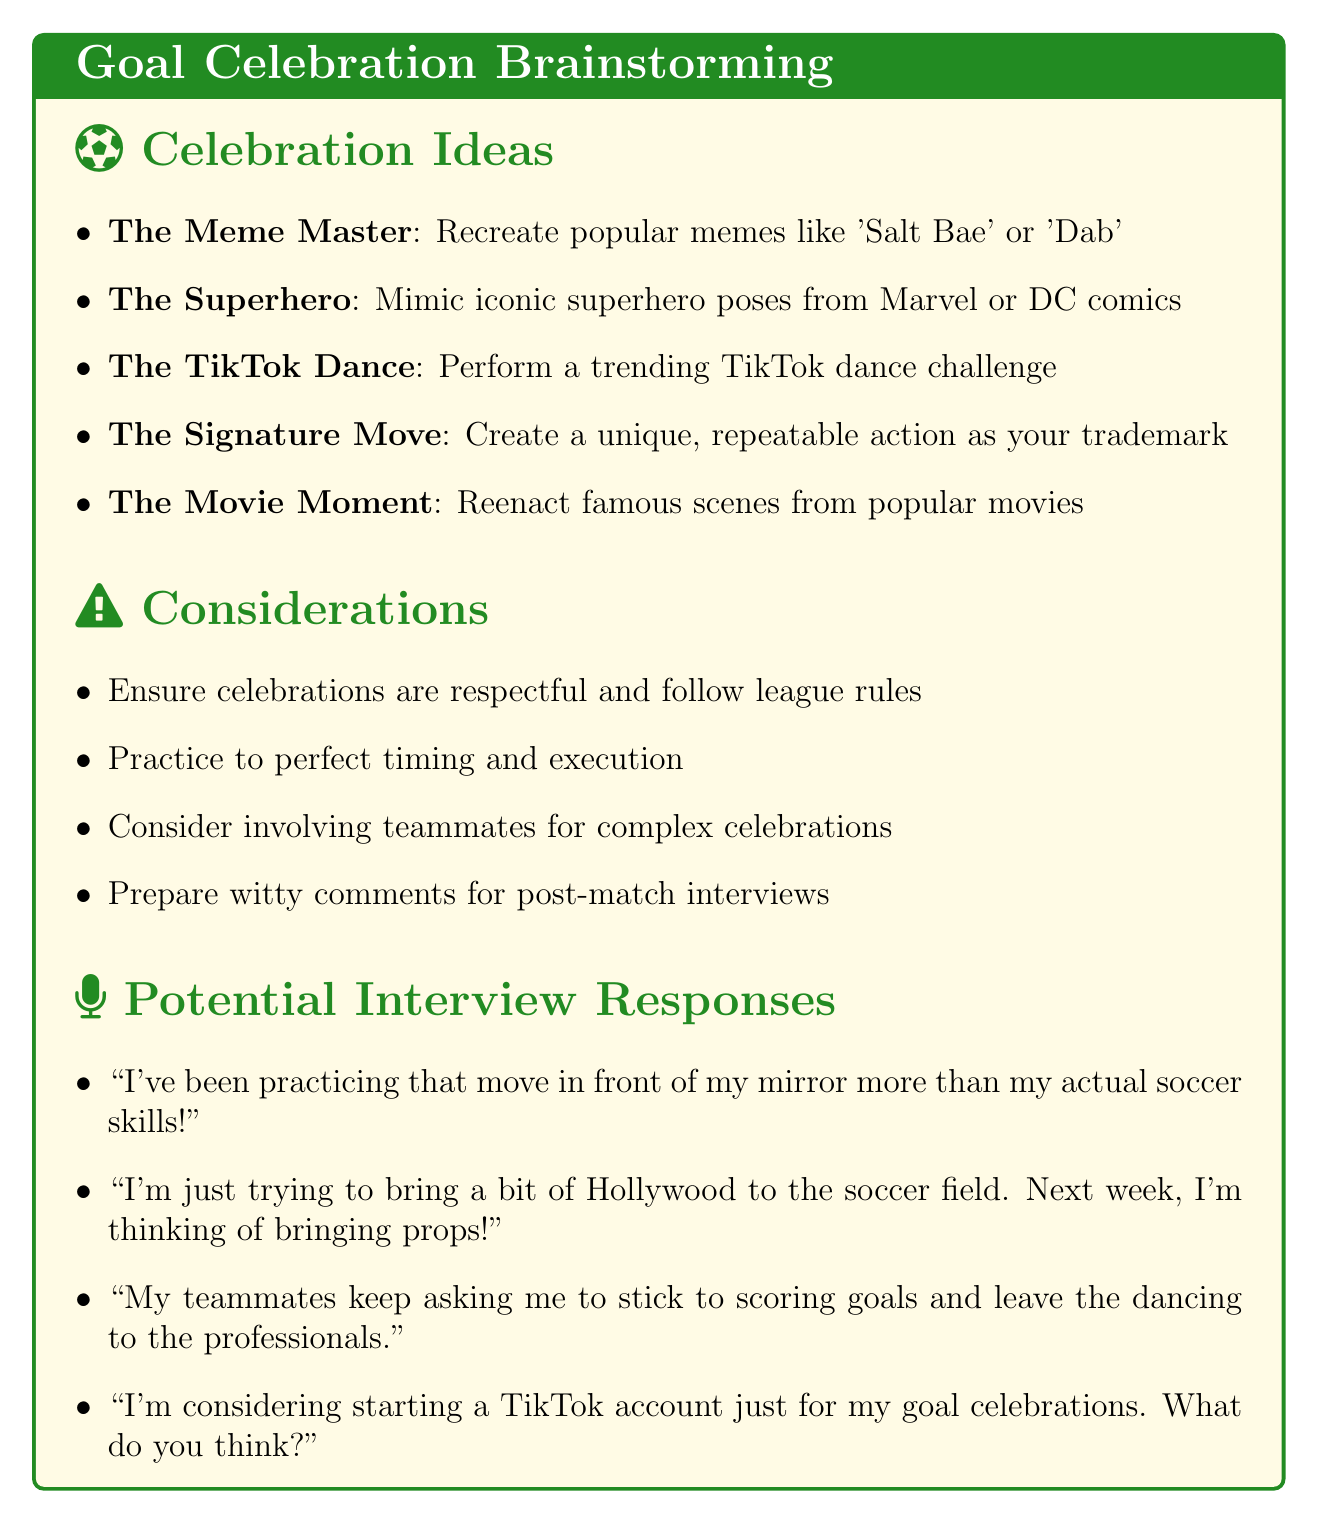What is the first goal celebration idea listed? The first goal celebration idea is titled "The Meme Master".
Answer: The Meme Master Which pop culture reference is associated with "The Superhero"? The Superhero is associated with superhero movies.
Answer: Superhero movies How many goal celebration ideas are presented in the document? There are five different goal celebration ideas mentioned.
Answer: Five What is one of the considerations listed for goal celebrations? One consideration is ensuring celebrations are respectful and follow league rules.
Answer: Ensure celebrations are respectful What might a player say about their practice for a celebration? The document suggests a potential interview response about practicing in front of a mirror.
Answer: I've been practicing that move in front of my mirror more than my actual soccer skills! What should players prepare for post-match interviews? Players should prepare witty comments for post-match interviews.
Answer: Witty comments Which celebration involves recreating scenes from movies? The goal celebration named "The Movie Moment" involves reenacting famous scenes.
Answer: The Movie Moment 